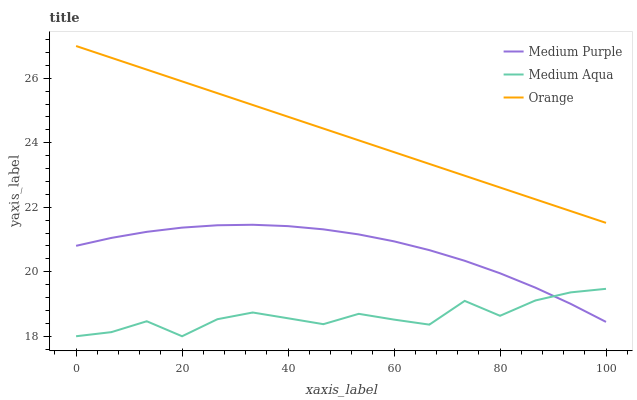Does Medium Aqua have the minimum area under the curve?
Answer yes or no. Yes. Does Orange have the maximum area under the curve?
Answer yes or no. Yes. Does Orange have the minimum area under the curve?
Answer yes or no. No. Does Medium Aqua have the maximum area under the curve?
Answer yes or no. No. Is Orange the smoothest?
Answer yes or no. Yes. Is Medium Aqua the roughest?
Answer yes or no. Yes. Is Medium Aqua the smoothest?
Answer yes or no. No. Is Orange the roughest?
Answer yes or no. No. Does Medium Aqua have the lowest value?
Answer yes or no. Yes. Does Orange have the lowest value?
Answer yes or no. No. Does Orange have the highest value?
Answer yes or no. Yes. Does Medium Aqua have the highest value?
Answer yes or no. No. Is Medium Purple less than Orange?
Answer yes or no. Yes. Is Orange greater than Medium Aqua?
Answer yes or no. Yes. Does Medium Aqua intersect Medium Purple?
Answer yes or no. Yes. Is Medium Aqua less than Medium Purple?
Answer yes or no. No. Is Medium Aqua greater than Medium Purple?
Answer yes or no. No. Does Medium Purple intersect Orange?
Answer yes or no. No. 